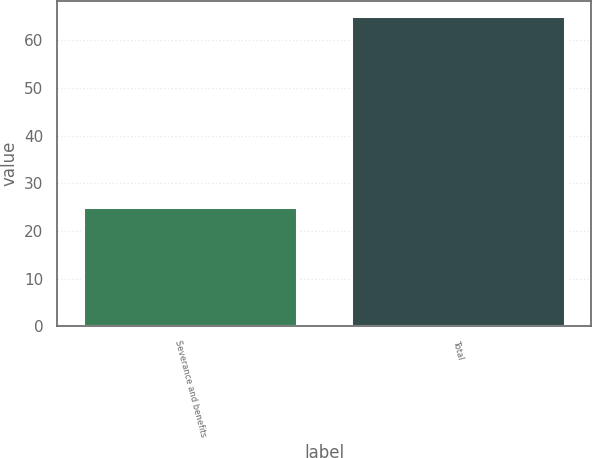Convert chart. <chart><loc_0><loc_0><loc_500><loc_500><bar_chart><fcel>Severance and benefits<fcel>Total<nl><fcel>25<fcel>65<nl></chart> 